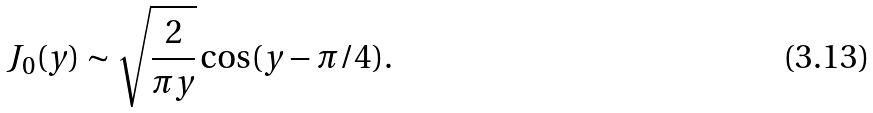<formula> <loc_0><loc_0><loc_500><loc_500>J _ { 0 } ( y ) \sim \sqrt { \frac { 2 } { \pi y } } \cos ( y - \pi / 4 ) .</formula> 